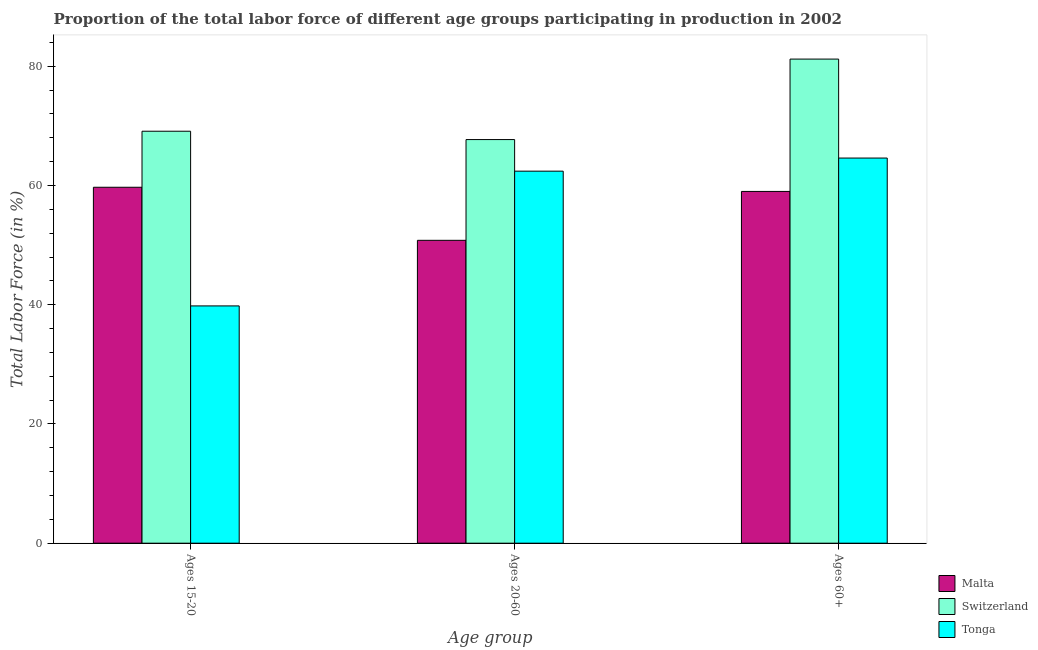Are the number of bars per tick equal to the number of legend labels?
Provide a short and direct response. Yes. Are the number of bars on each tick of the X-axis equal?
Offer a terse response. Yes. How many bars are there on the 1st tick from the left?
Offer a terse response. 3. What is the label of the 3rd group of bars from the left?
Your answer should be very brief. Ages 60+. What is the percentage of labor force within the age group 15-20 in Switzerland?
Provide a short and direct response. 69.1. Across all countries, what is the maximum percentage of labor force within the age group 15-20?
Provide a short and direct response. 69.1. Across all countries, what is the minimum percentage of labor force above age 60?
Your answer should be very brief. 59. In which country was the percentage of labor force above age 60 maximum?
Offer a terse response. Switzerland. In which country was the percentage of labor force within the age group 15-20 minimum?
Offer a terse response. Tonga. What is the total percentage of labor force above age 60 in the graph?
Your answer should be compact. 204.8. What is the difference between the percentage of labor force within the age group 15-20 in Tonga and that in Malta?
Offer a very short reply. -19.9. What is the difference between the percentage of labor force above age 60 in Tonga and the percentage of labor force within the age group 15-20 in Switzerland?
Ensure brevity in your answer.  -4.5. What is the average percentage of labor force above age 60 per country?
Keep it short and to the point. 68.27. What is the difference between the percentage of labor force within the age group 20-60 and percentage of labor force within the age group 15-20 in Malta?
Keep it short and to the point. -8.9. What is the ratio of the percentage of labor force within the age group 15-20 in Malta to that in Tonga?
Keep it short and to the point. 1.5. Is the percentage of labor force within the age group 20-60 in Switzerland less than that in Tonga?
Ensure brevity in your answer.  No. Is the difference between the percentage of labor force above age 60 in Switzerland and Malta greater than the difference between the percentage of labor force within the age group 20-60 in Switzerland and Malta?
Offer a terse response. Yes. What is the difference between the highest and the second highest percentage of labor force above age 60?
Your response must be concise. 16.6. What is the difference between the highest and the lowest percentage of labor force above age 60?
Give a very brief answer. 22.2. In how many countries, is the percentage of labor force within the age group 20-60 greater than the average percentage of labor force within the age group 20-60 taken over all countries?
Your response must be concise. 2. Is the sum of the percentage of labor force within the age group 15-20 in Malta and Switzerland greater than the maximum percentage of labor force above age 60 across all countries?
Your response must be concise. Yes. What does the 1st bar from the left in Ages 20-60 represents?
Give a very brief answer. Malta. What does the 3rd bar from the right in Ages 20-60 represents?
Offer a very short reply. Malta. How many bars are there?
Give a very brief answer. 9. How many countries are there in the graph?
Ensure brevity in your answer.  3. What is the difference between two consecutive major ticks on the Y-axis?
Offer a terse response. 20. Does the graph contain any zero values?
Provide a succinct answer. No. Where does the legend appear in the graph?
Keep it short and to the point. Bottom right. What is the title of the graph?
Offer a terse response. Proportion of the total labor force of different age groups participating in production in 2002. Does "Armenia" appear as one of the legend labels in the graph?
Ensure brevity in your answer.  No. What is the label or title of the X-axis?
Your answer should be very brief. Age group. What is the label or title of the Y-axis?
Give a very brief answer. Total Labor Force (in %). What is the Total Labor Force (in %) of Malta in Ages 15-20?
Offer a terse response. 59.7. What is the Total Labor Force (in %) of Switzerland in Ages 15-20?
Make the answer very short. 69.1. What is the Total Labor Force (in %) in Tonga in Ages 15-20?
Your answer should be very brief. 39.8. What is the Total Labor Force (in %) of Malta in Ages 20-60?
Keep it short and to the point. 50.8. What is the Total Labor Force (in %) in Switzerland in Ages 20-60?
Provide a short and direct response. 67.7. What is the Total Labor Force (in %) of Tonga in Ages 20-60?
Your response must be concise. 62.4. What is the Total Labor Force (in %) in Switzerland in Ages 60+?
Your answer should be very brief. 81.2. What is the Total Labor Force (in %) in Tonga in Ages 60+?
Ensure brevity in your answer.  64.6. Across all Age group, what is the maximum Total Labor Force (in %) in Malta?
Offer a very short reply. 59.7. Across all Age group, what is the maximum Total Labor Force (in %) of Switzerland?
Offer a terse response. 81.2. Across all Age group, what is the maximum Total Labor Force (in %) in Tonga?
Your response must be concise. 64.6. Across all Age group, what is the minimum Total Labor Force (in %) in Malta?
Keep it short and to the point. 50.8. Across all Age group, what is the minimum Total Labor Force (in %) of Switzerland?
Your response must be concise. 67.7. Across all Age group, what is the minimum Total Labor Force (in %) in Tonga?
Offer a very short reply. 39.8. What is the total Total Labor Force (in %) in Malta in the graph?
Provide a succinct answer. 169.5. What is the total Total Labor Force (in %) of Switzerland in the graph?
Offer a terse response. 218. What is the total Total Labor Force (in %) of Tonga in the graph?
Offer a very short reply. 166.8. What is the difference between the Total Labor Force (in %) of Malta in Ages 15-20 and that in Ages 20-60?
Your answer should be very brief. 8.9. What is the difference between the Total Labor Force (in %) in Tonga in Ages 15-20 and that in Ages 20-60?
Give a very brief answer. -22.6. What is the difference between the Total Labor Force (in %) in Malta in Ages 15-20 and that in Ages 60+?
Give a very brief answer. 0.7. What is the difference between the Total Labor Force (in %) of Switzerland in Ages 15-20 and that in Ages 60+?
Make the answer very short. -12.1. What is the difference between the Total Labor Force (in %) of Tonga in Ages 15-20 and that in Ages 60+?
Your response must be concise. -24.8. What is the difference between the Total Labor Force (in %) of Malta in Ages 20-60 and that in Ages 60+?
Provide a short and direct response. -8.2. What is the difference between the Total Labor Force (in %) in Switzerland in Ages 20-60 and that in Ages 60+?
Provide a short and direct response. -13.5. What is the difference between the Total Labor Force (in %) in Tonga in Ages 20-60 and that in Ages 60+?
Provide a succinct answer. -2.2. What is the difference between the Total Labor Force (in %) in Switzerland in Ages 15-20 and the Total Labor Force (in %) in Tonga in Ages 20-60?
Your answer should be very brief. 6.7. What is the difference between the Total Labor Force (in %) of Malta in Ages 15-20 and the Total Labor Force (in %) of Switzerland in Ages 60+?
Make the answer very short. -21.5. What is the difference between the Total Labor Force (in %) in Malta in Ages 15-20 and the Total Labor Force (in %) in Tonga in Ages 60+?
Offer a very short reply. -4.9. What is the difference between the Total Labor Force (in %) of Switzerland in Ages 15-20 and the Total Labor Force (in %) of Tonga in Ages 60+?
Keep it short and to the point. 4.5. What is the difference between the Total Labor Force (in %) in Malta in Ages 20-60 and the Total Labor Force (in %) in Switzerland in Ages 60+?
Offer a very short reply. -30.4. What is the difference between the Total Labor Force (in %) of Malta in Ages 20-60 and the Total Labor Force (in %) of Tonga in Ages 60+?
Provide a short and direct response. -13.8. What is the difference between the Total Labor Force (in %) in Switzerland in Ages 20-60 and the Total Labor Force (in %) in Tonga in Ages 60+?
Your response must be concise. 3.1. What is the average Total Labor Force (in %) of Malta per Age group?
Provide a short and direct response. 56.5. What is the average Total Labor Force (in %) in Switzerland per Age group?
Provide a short and direct response. 72.67. What is the average Total Labor Force (in %) of Tonga per Age group?
Your answer should be very brief. 55.6. What is the difference between the Total Labor Force (in %) of Malta and Total Labor Force (in %) of Switzerland in Ages 15-20?
Offer a terse response. -9.4. What is the difference between the Total Labor Force (in %) in Malta and Total Labor Force (in %) in Tonga in Ages 15-20?
Keep it short and to the point. 19.9. What is the difference between the Total Labor Force (in %) of Switzerland and Total Labor Force (in %) of Tonga in Ages 15-20?
Offer a very short reply. 29.3. What is the difference between the Total Labor Force (in %) in Malta and Total Labor Force (in %) in Switzerland in Ages 20-60?
Give a very brief answer. -16.9. What is the difference between the Total Labor Force (in %) in Switzerland and Total Labor Force (in %) in Tonga in Ages 20-60?
Keep it short and to the point. 5.3. What is the difference between the Total Labor Force (in %) in Malta and Total Labor Force (in %) in Switzerland in Ages 60+?
Provide a short and direct response. -22.2. What is the ratio of the Total Labor Force (in %) of Malta in Ages 15-20 to that in Ages 20-60?
Keep it short and to the point. 1.18. What is the ratio of the Total Labor Force (in %) in Switzerland in Ages 15-20 to that in Ages 20-60?
Ensure brevity in your answer.  1.02. What is the ratio of the Total Labor Force (in %) of Tonga in Ages 15-20 to that in Ages 20-60?
Give a very brief answer. 0.64. What is the ratio of the Total Labor Force (in %) of Malta in Ages 15-20 to that in Ages 60+?
Provide a succinct answer. 1.01. What is the ratio of the Total Labor Force (in %) of Switzerland in Ages 15-20 to that in Ages 60+?
Offer a terse response. 0.85. What is the ratio of the Total Labor Force (in %) of Tonga in Ages 15-20 to that in Ages 60+?
Make the answer very short. 0.62. What is the ratio of the Total Labor Force (in %) in Malta in Ages 20-60 to that in Ages 60+?
Your response must be concise. 0.86. What is the ratio of the Total Labor Force (in %) of Switzerland in Ages 20-60 to that in Ages 60+?
Offer a very short reply. 0.83. What is the ratio of the Total Labor Force (in %) in Tonga in Ages 20-60 to that in Ages 60+?
Offer a terse response. 0.97. What is the difference between the highest and the second highest Total Labor Force (in %) of Switzerland?
Keep it short and to the point. 12.1. What is the difference between the highest and the lowest Total Labor Force (in %) of Malta?
Your answer should be very brief. 8.9. What is the difference between the highest and the lowest Total Labor Force (in %) of Tonga?
Your answer should be compact. 24.8. 